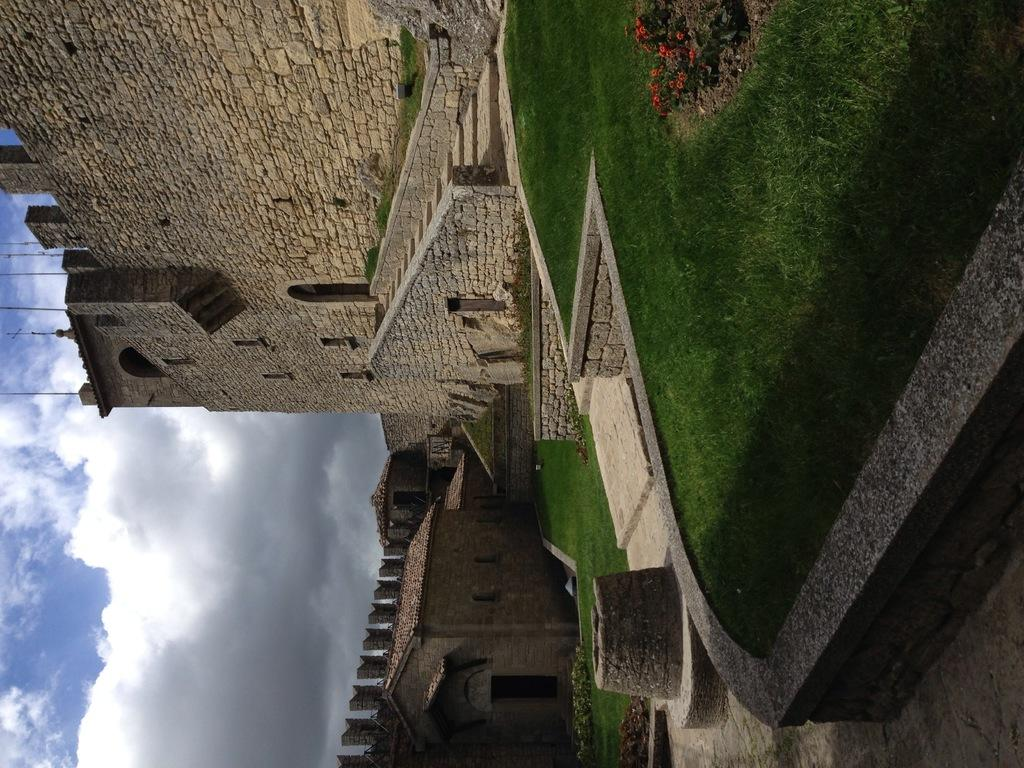What type of structures can be seen in the image? There are houses in the image. What architectural feature is present in the image? There are stairs in the image. What type of terrain is visible in the image? There is grassland in the image. What is located above the houses in the image? There are poles above the houses in the image. What type of liquid can be seen flowing through the houses in the image? There is no liquid flowing through the houses in the image; the image only shows houses, stairs, grassland, and poles. 